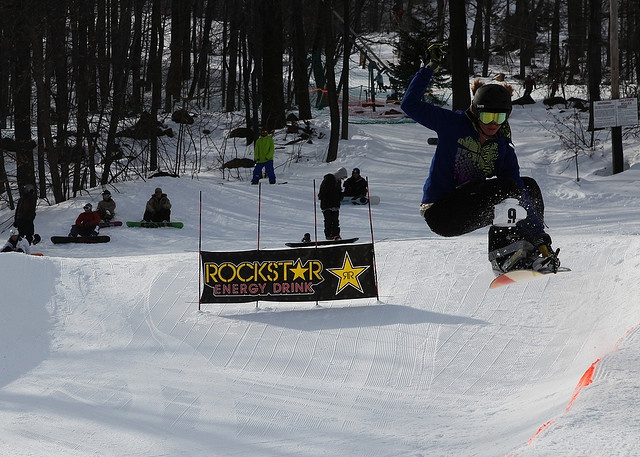Describe the objects in this image and their specific colors. I can see people in black, gray, darkgray, and navy tones, people in black and gray tones, people in black, gray, and darkgray tones, people in black, darkgreen, and gray tones, and people in black and gray tones in this image. 